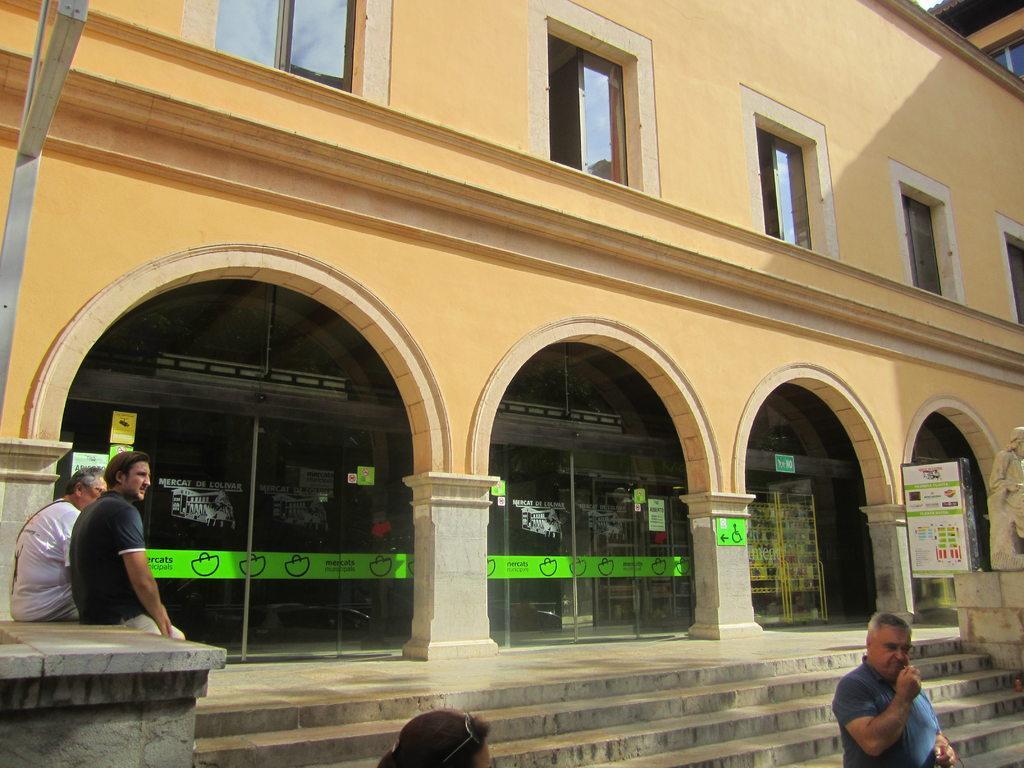Describe this image in one or two sentences. In this image I can see a building with glass doors and windows I can see some people, a statue, a board with some text. I can see some labels and stickers on the glass with some text. 